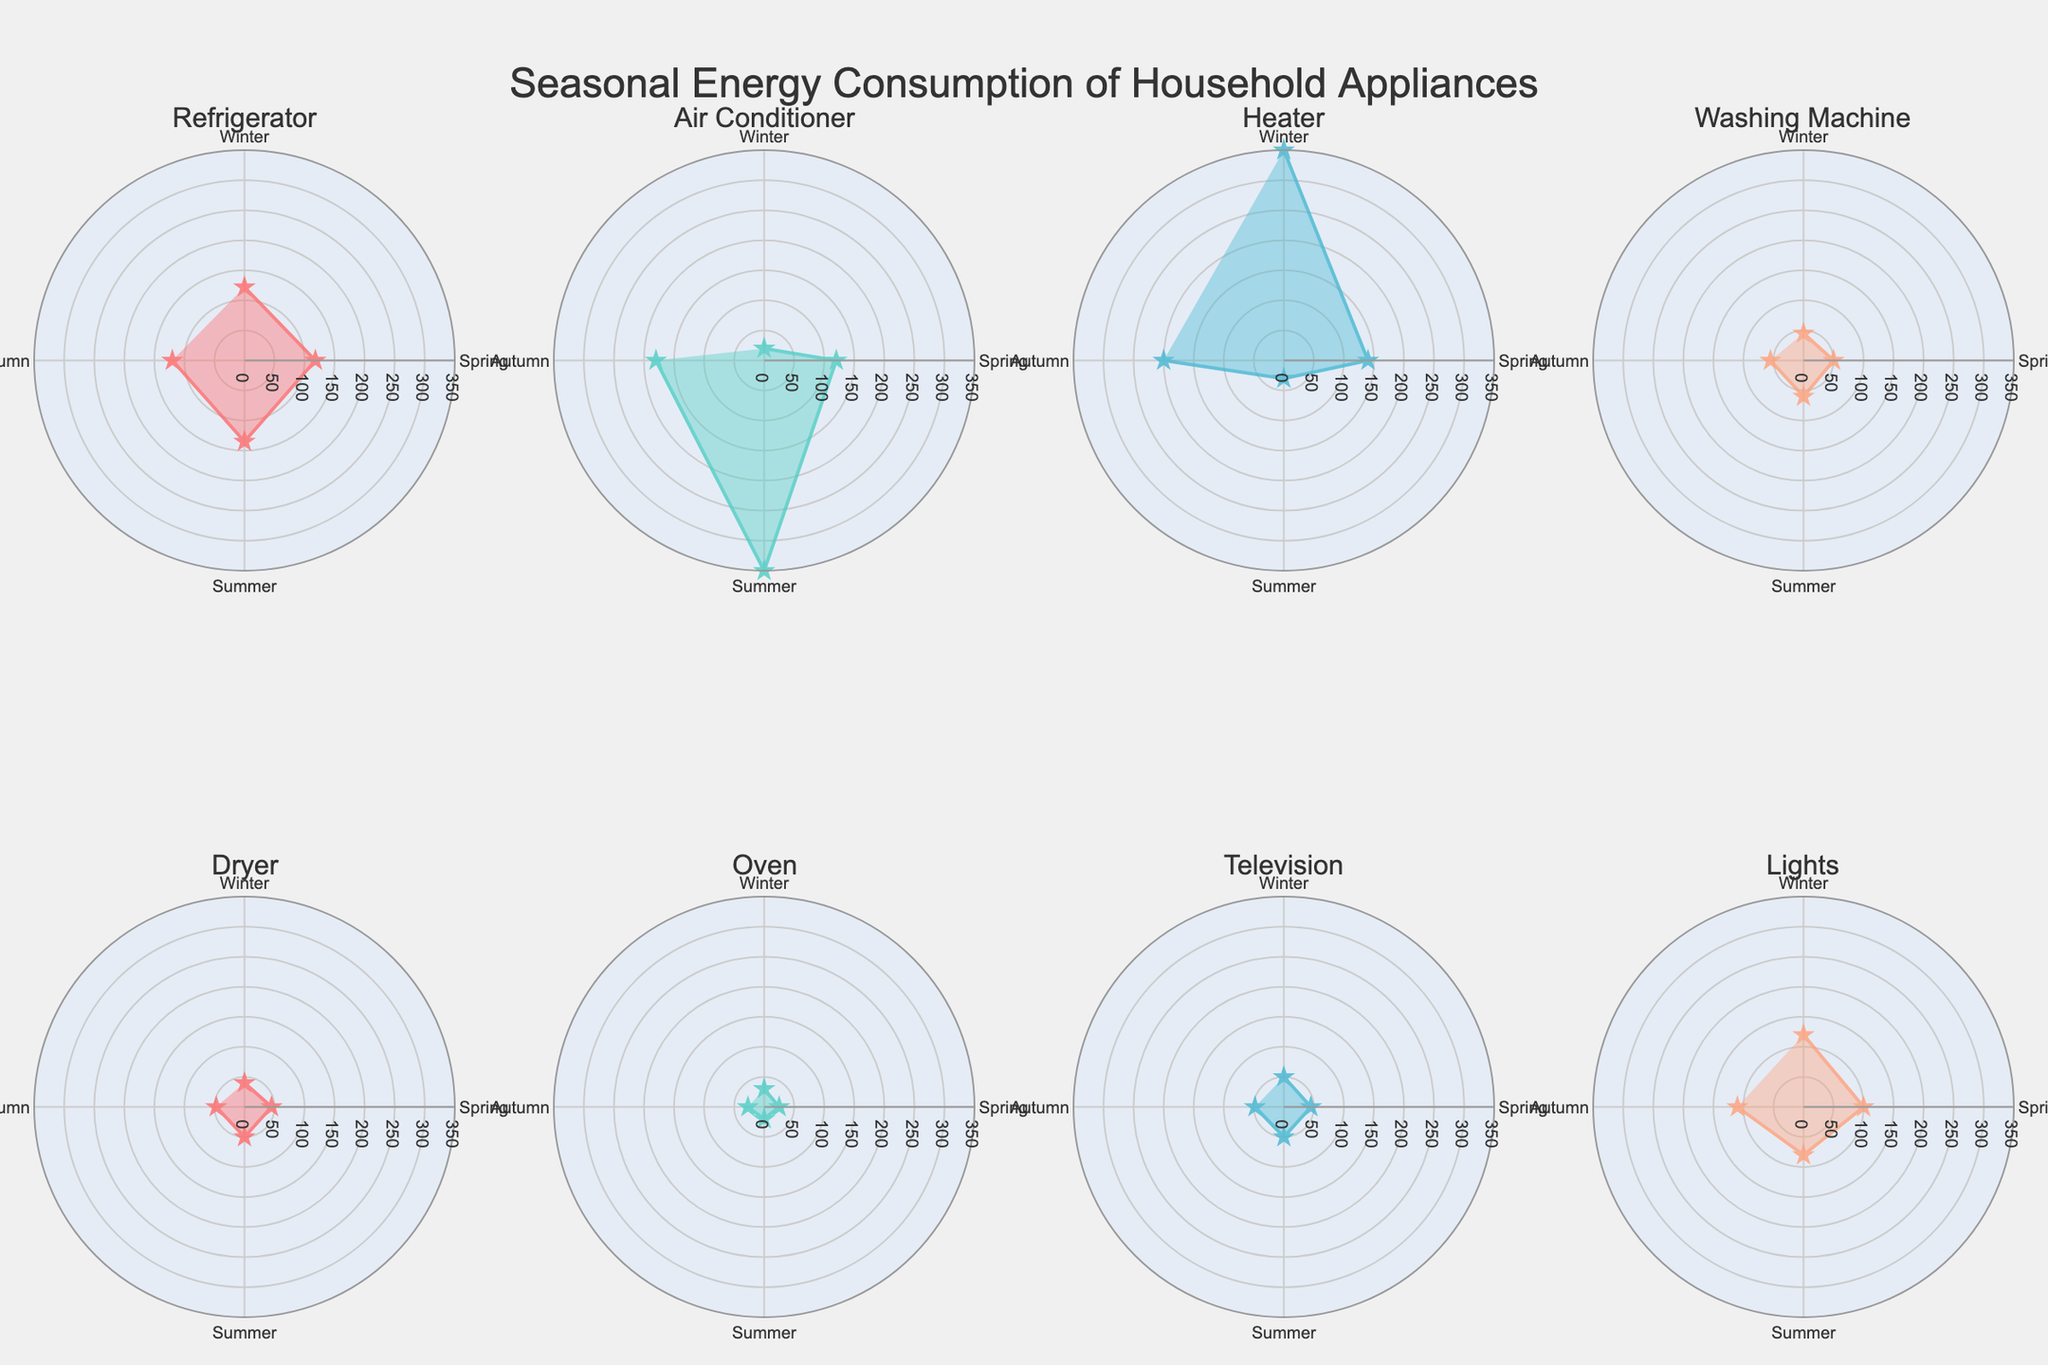Which appliance has the highest energy consumption in summer? Look at each subplot, find the highest value in the "Summer" season, the air conditioner mentions 350 kWh, the rest are below this value.
Answer: Air Conditioner Which appliance consumes the most energy in winter? Check each subplot for the "Winter" season. The heater has 350 kWh, which is the highest.
Answer: Heater How many appliances have their peak consumption in summer? Check each appliance's plot and note if the summer consumption is the highest. Only the air conditioner has its peak consumption in summer.
Answer: 1 Which season has the lowest total energy consumption for all appliances combined? Sum energy consumption for each appliance in each season: Winter (122+20+350+45+40+30+50+120=777), Spring (118+120+140+50+45+25+45+100=643), Summer (135+350+30+60+50+20+50+80=775), Autumn (120+180+200+55+47+27+48+110=787). Spring has the lowest total.
Answer: Spring What is the difference in energy consumption for the heater between winter and summer? Check the heater’s winter (350 kWh) and summer (30 kWh) energy consumption, subtract them (350-30).
Answer: 320 Which appliance's energy consumption varies the most between seasons? Calculate the range for each appliance: Refrigerator (135-118=17), Air Conditioner (350-20=330), Heater (350-30=320), Washing Machine (60-45=15), Dryer (50-40=10), Oven (30-20=10), Television (50-45=5), Lights (120-80=40). The air conditioner has the largest range.
Answer: Air Conditioner What’s the average energy consumption of the refrigerator across all seasons? Sum the refrigerator's consumption in each season (122+118+135+120=495) and divide by the number of seasons (4).
Answer: 123.75 How does the energy consumption of lights in winter compare to its consumption in summer? Compare the lights consumption for winter (120 kWh) and summer (80 kWh); winter is greater.
Answer: Winter is higher Explain the trend in energy consumption for the air conditioner throughout the year. During winter, the air conditioner consumes 20 kWh. The consumption rises sharply in spring to 120 kWh, peaks in summer at 350 kWh, then drops to 180 kWh in autumn. This indicates increased use during warmer seasons.
Answer: Peaks in summer Which two appliances have the closest energy consumption in autumn? Look at energy consumption in autumn for each appliance: Refrigerator (120), Air Conditioner (180), Heater (200), Washing Machine (55), Dryer (47), Oven (27), Television (48), Lights (110). Dryer and Television have the closest values of 47 and 48 kWh.
Answer: Dryer and Television 